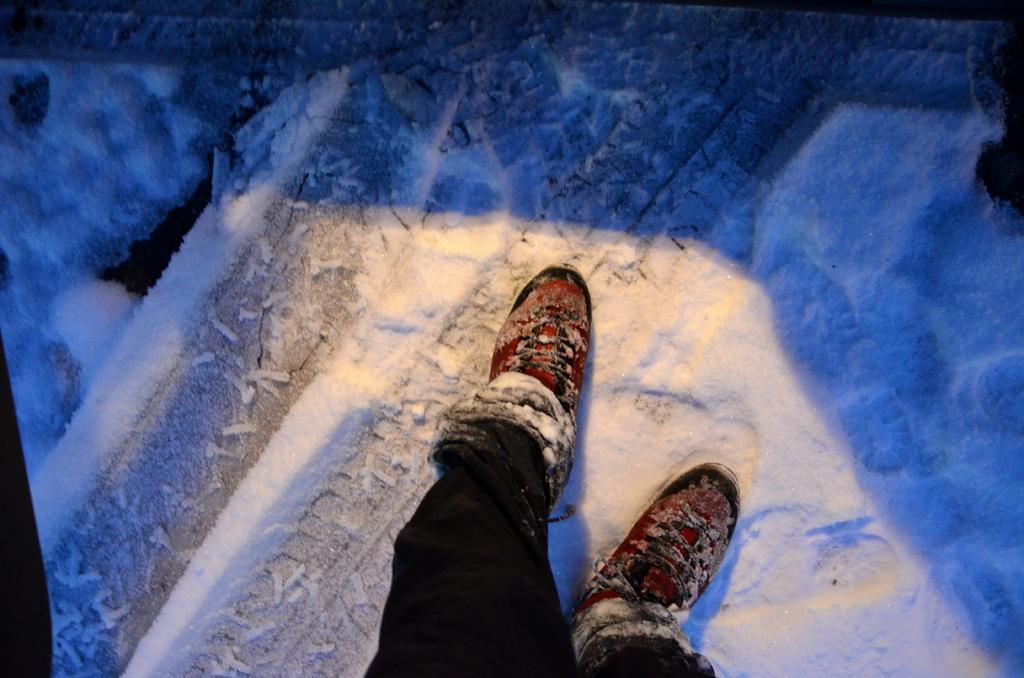How would you summarize this image in a sentence or two? In the image we can see human legs wearing clothes and shoes. Everywhere there is the snow, white in color. 